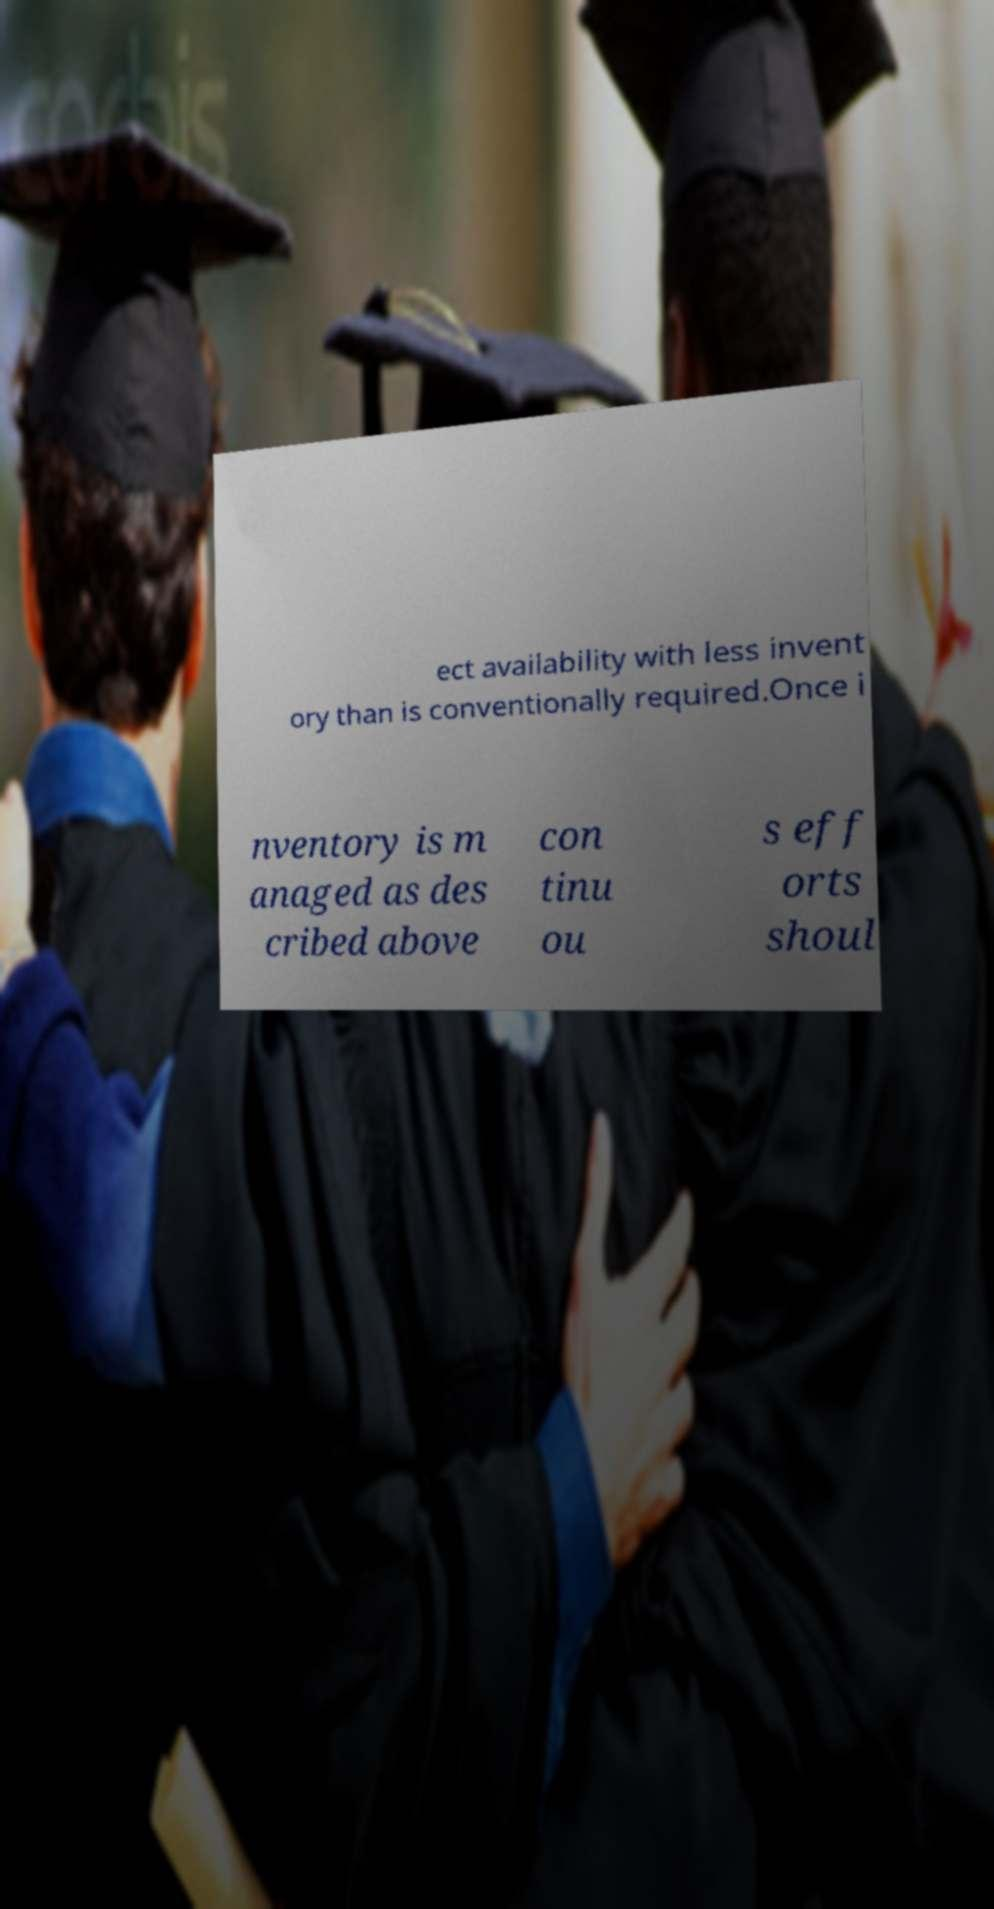There's text embedded in this image that I need extracted. Can you transcribe it verbatim? ect availability with less invent ory than is conventionally required.Once i nventory is m anaged as des cribed above con tinu ou s eff orts shoul 